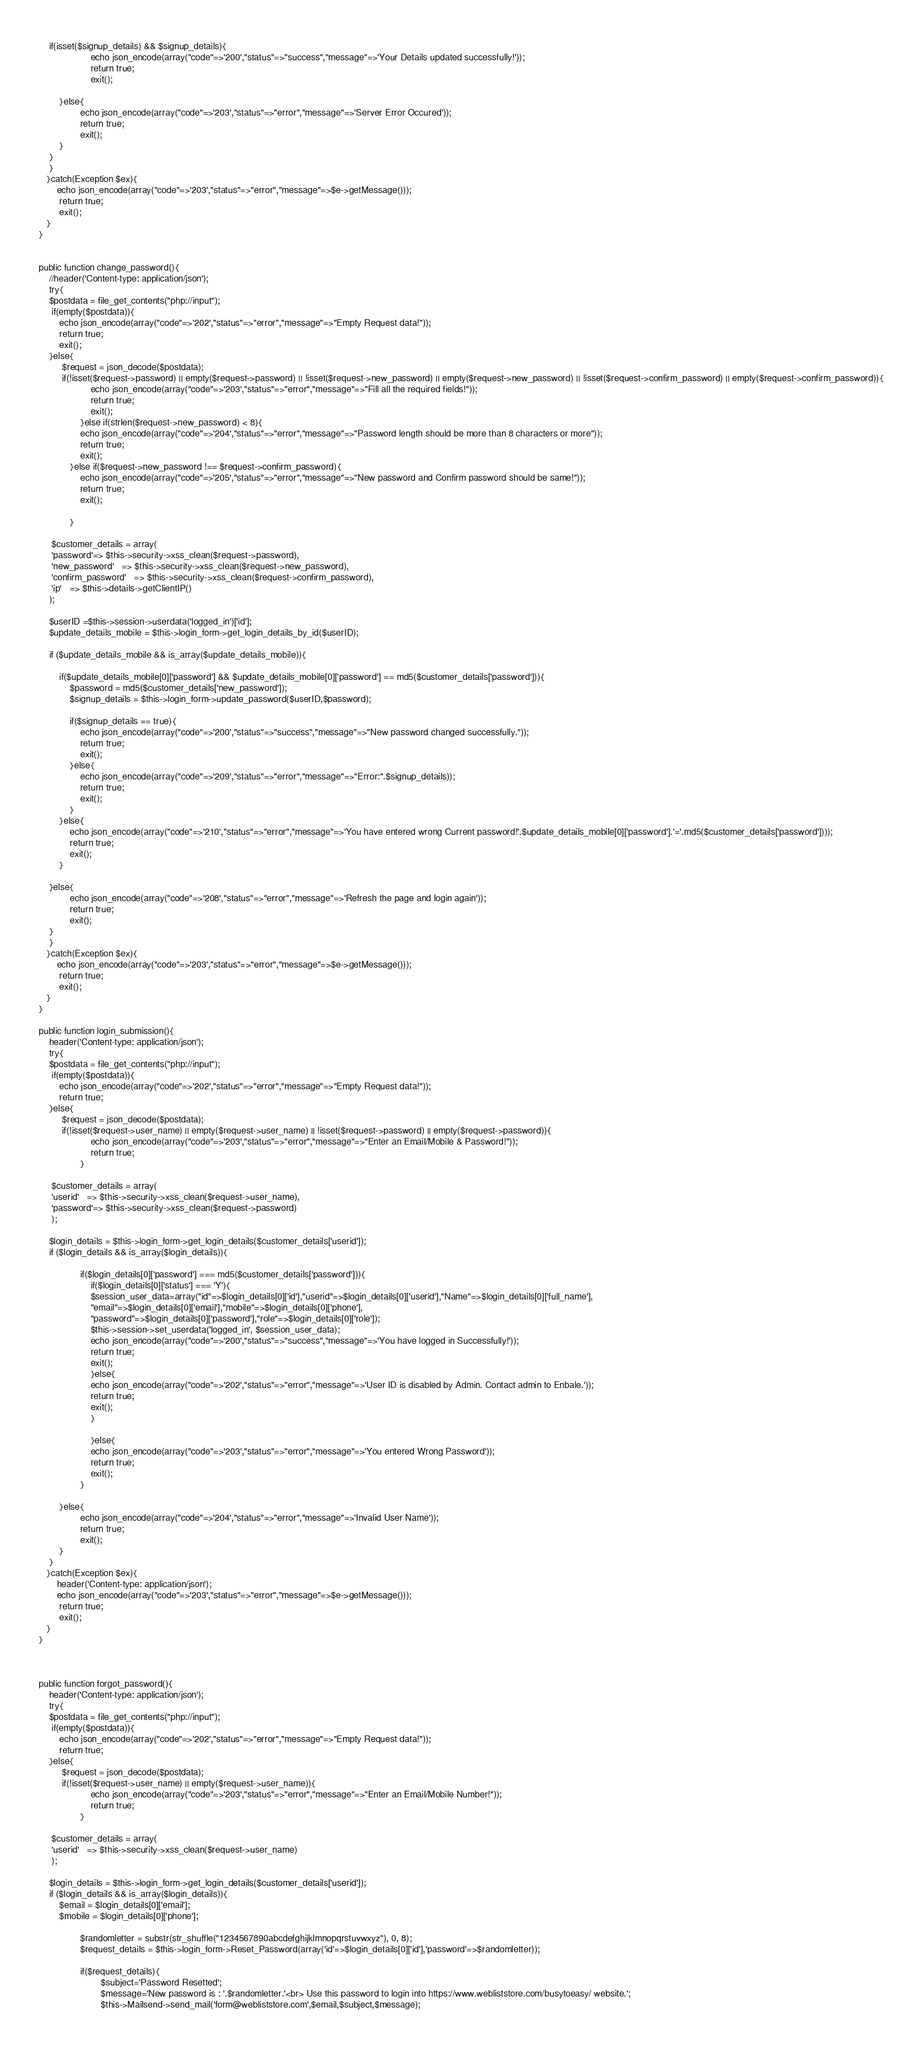<code> <loc_0><loc_0><loc_500><loc_500><_PHP_>        
        if(isset($signup_details) && $signup_details){
                        echo json_encode(array("code"=>'200',"status"=>"success","message"=>'Your Details updated successfully!'));
                        return true;
                        exit();
            
            }else{
                    echo json_encode(array("code"=>'203',"status"=>"error","message"=>'Server Error Occured'));
                    return true;
                    exit();
            }
        }
        }
	   }catch(Exception $ex){
	       echo json_encode(array("code"=>'203',"status"=>"error","message"=>$e->getMessage()));
            return true;
            exit();
	   }
	}
	
	
	public function change_password(){
	    //header('Content-type: application/json');
	    try{
	    $postdata = file_get_contents("php://input");
	     if(empty($postdata)){
            echo json_encode(array("code"=>'202',"status"=>"error","message"=>"Empty Request data!"));
            return true;
            exit();
        }else{
	         $request = json_decode($postdata);
    	     if(!isset($request->password) || empty($request->password) || !isset($request->new_password) || empty($request->new_password) || !isset($request->confirm_password) || empty($request->confirm_password)){
                        echo json_encode(array("code"=>'203',"status"=>"error","message"=>"Fill all the required fields!"));
                        return true;
                        exit();
                    }else if(strlen($request->new_password) < 8){
                    echo json_encode(array("code"=>'204',"status"=>"error","message"=>"Password length should be more than 8 characters or more"));
                    return true;
                    exit();
                }else if($request->new_password !== $request->confirm_password){
                    echo json_encode(array("code"=>'205',"status"=>"error","message"=>"New password and Confirm password should be same!"));
                    return true;
                    exit();
                    
                }
            
         $customer_details = array(
         'password'=> $this->security->xss_clean($request->password),
         'new_password'   => $this->security->xss_clean($request->new_password),
         'confirm_password'   => $this->security->xss_clean($request->confirm_password),
         'ip'   => $this->details->getClientIP()
        );
        
        $userID =$this->session->userdata('logged_in')['id'];
        $update_details_mobile = $this->login_form->get_login_details_by_id($userID);
        
        if ($update_details_mobile && is_array($update_details_mobile)){
            
            if($update_details_mobile[0]['password'] && $update_details_mobile[0]['password'] == md5($customer_details['password'])){
                $password = md5($customer_details['new_password']);
                $signup_details = $this->login_form->update_password($userID,$password);
                
                if($signup_details == true){
                    echo json_encode(array("code"=>'200',"status"=>"success","message"=>"New password changed successfully."));
                    return true;
                    exit();
                }else{
                    echo json_encode(array("code"=>'209',"status"=>"error","message"=>"Error:".$signup_details));
                    return true;
                    exit();
                }
            }else{
                echo json_encode(array("code"=>'210',"status"=>"error","message"=>'You have entered wrong Current password!'.$update_details_mobile[0]['password'].'='.md5($customer_details['password'])));
                return true;
                exit();
            }
            
        }else{
                echo json_encode(array("code"=>'208',"status"=>"error","message"=>'Refresh the page and login again'));
                return true;
                exit();
        }
        }
	   }catch(Exception $ex){
	       echo json_encode(array("code"=>'203',"status"=>"error","message"=>$e->getMessage()));
            return true;
            exit();
	   }
	}
	
	public function login_submission(){
	    header('Content-type: application/json');
	    try{
	    $postdata = file_get_contents("php://input");
	     if(empty($postdata)){
            echo json_encode(array("code"=>'202',"status"=>"error","message"=>"Empty Request data!"));
            return true;
        }else{
	         $request = json_decode($postdata);
    	     if(!isset($request->user_name) || empty($request->user_name) || !isset($request->password) || empty($request->password)){
                        echo json_encode(array("code"=>'203',"status"=>"error","message"=>"Enter an Email/Mobile & Password!"));
                        return true;
                    }
         
         $customer_details = array(
         'userid'   => $this->security->xss_clean($request->user_name),
         'password'=> $this->security->xss_clean($request->password)
         );
      
        $login_details = $this->login_form->get_login_details($customer_details['userid']);
        if ($login_details && is_array($login_details)){
            
                    if($login_details[0]['password'] === md5($customer_details['password'])){
                        if($login_details[0]['status'] === 'Y'){
                        $session_user_data=array("id"=>$login_details[0]['id'],"userid"=>$login_details[0]['userid'],"Name"=>$login_details[0]['full_name'],
                        "email"=>$login_details[0]['email'],"mobile"=>$login_details[0]['phone'],
                        "password"=>$login_details[0]['password'],"role"=>$login_details[0]['role']);
                        $this->session->set_userdata('logged_in', $session_user_data);
                        echo json_encode(array("code"=>'200',"status"=>"success","message"=>'You have logged in Successfully!'));
                        return true;
                        exit();
                        }else{
                        echo json_encode(array("code"=>'202',"status"=>"error","message"=>'User ID is disabled by Admin. Contact admin to Enbale.'));
                        return true;
                        exit();
                        }
                        
                        }else{
                        echo json_encode(array("code"=>'203',"status"=>"error","message"=>'You entered Wrong Password'));
                        return true;
                        exit();
                    }
            
            }else{
                    echo json_encode(array("code"=>'204',"status"=>"error","message"=>'Invalid User Name'));
                    return true;
                    exit();
            }
        }
	   }catch(Exception $ex){
	       header('Content-type: application/json');
	       echo json_encode(array("code"=>'203',"status"=>"error","message"=>$e->getMessage()));
            return true;
            exit();
	   }
	}
	
	
	
	public function forgot_password(){
	    header('Content-type: application/json');
	    try{
	    $postdata = file_get_contents("php://input");
	     if(empty($postdata)){
            echo json_encode(array("code"=>'202',"status"=>"error","message"=>"Empty Request data!"));
            return true;
        }else{
	         $request = json_decode($postdata);
    	     if(!isset($request->user_name) || empty($request->user_name)){
                        echo json_encode(array("code"=>'203',"status"=>"error","message"=>"Enter an Email/Mobile Number!"));
                        return true;
                    }
         
         $customer_details = array(
         'userid'   => $this->security->xss_clean($request->user_name)
         );
      
        $login_details = $this->login_form->get_login_details($customer_details['userid']);
        if ($login_details && is_array($login_details)){
            $email = $login_details[0]['email'];
            $mobile = $login_details[0]['phone'];
            
                    $randomletter = substr(str_shuffle("1234567890abcdefghijklmnopqrstuvwxyz"), 0, 8);
                    $request_details = $this->login_form->Reset_Password(array('id'=>$login_details[0]['id'],'password'=>$randomletter));
            
                    if($request_details){
                            $subject='Password Resetted';
                            $message='New password is : '.$randomletter.'<br> Use this password to login into https://www.webliststore.com/busytoeasy/ website.';
                            $this->Mailsend->send_mail('form@webliststore.com',$email,$subject,$message);
                            </code> 